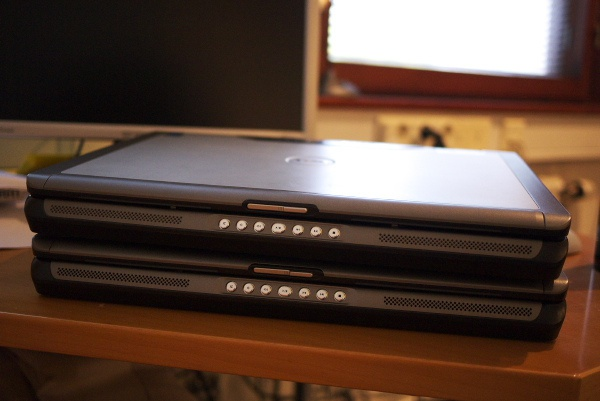Describe the objects in this image and their specific colors. I can see laptop in black, white, and gray tones, tv in black, maroon, and brown tones, and laptop in black, maroon, and gray tones in this image. 